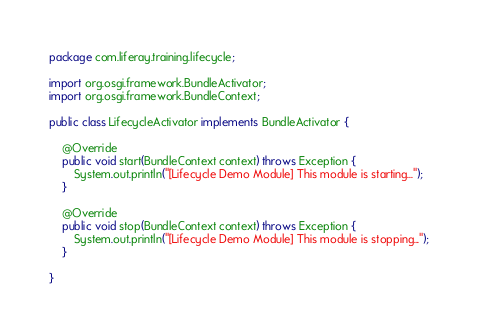Convert code to text. <code><loc_0><loc_0><loc_500><loc_500><_Java_>package com.liferay.training.lifecycle;

import org.osgi.framework.BundleActivator;
import org.osgi.framework.BundleContext;

public class LifecycleActivator implements BundleActivator {

	@Override
	public void start(BundleContext context) throws Exception {
		System.out.println("[Lifecycle Demo Module] This module is starting...");
	}

	@Override
	public void stop(BundleContext context) throws Exception {
		System.out.println("[Lifecycle Demo Module] This module is stopping...");
	}

}</code> 